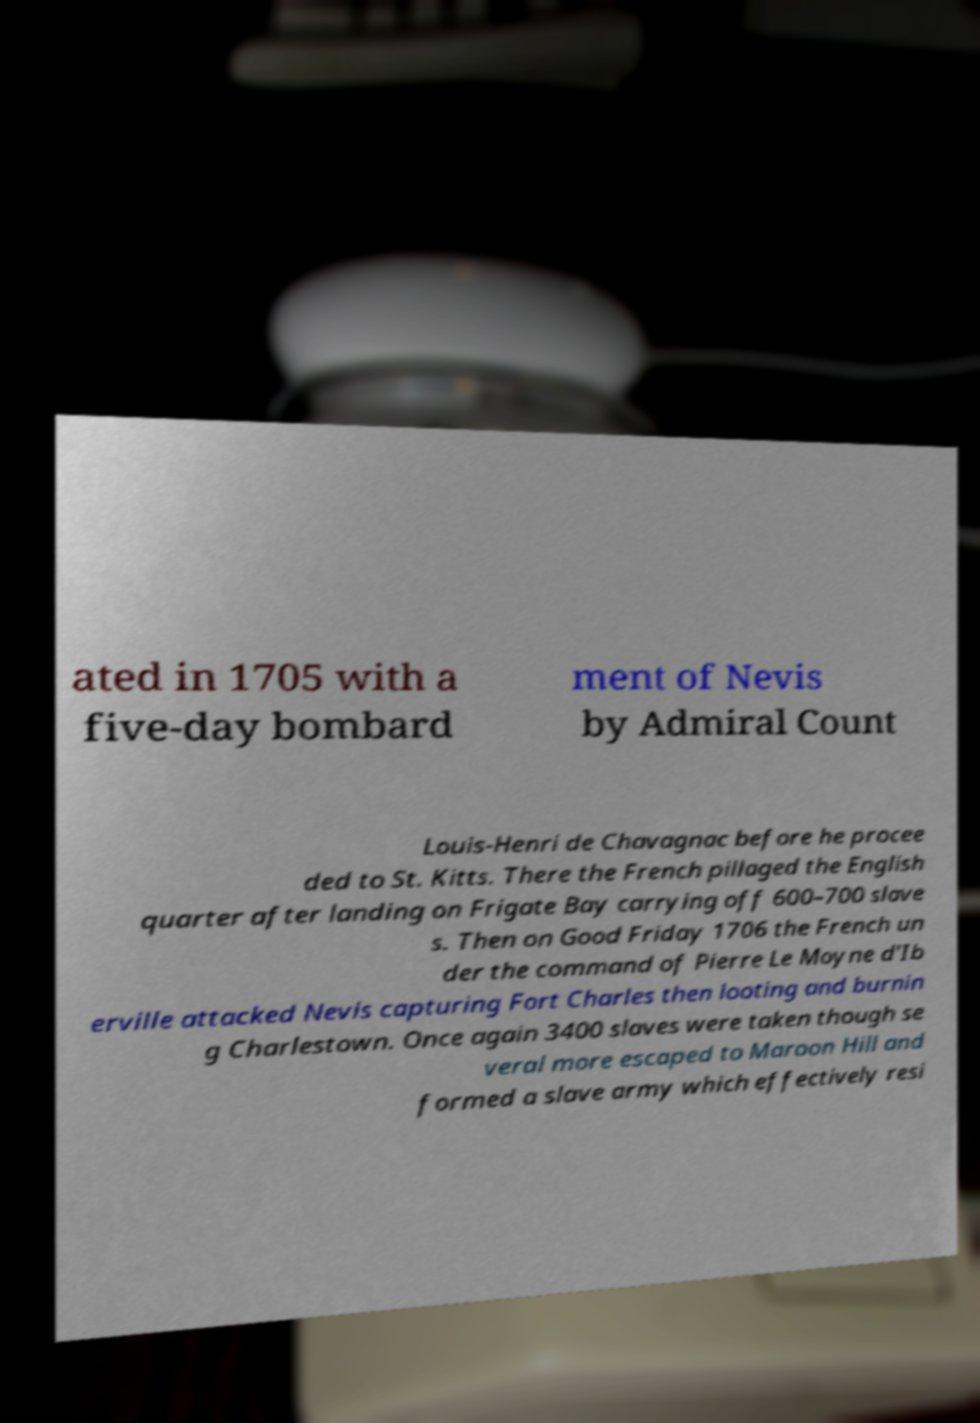Could you extract and type out the text from this image? ated in 1705 with a five-day bombard ment of Nevis by Admiral Count Louis-Henri de Chavagnac before he procee ded to St. Kitts. There the French pillaged the English quarter after landing on Frigate Bay carrying off 600–700 slave s. Then on Good Friday 1706 the French un der the command of Pierre Le Moyne d'Ib erville attacked Nevis capturing Fort Charles then looting and burnin g Charlestown. Once again 3400 slaves were taken though se veral more escaped to Maroon Hill and formed a slave army which effectively resi 